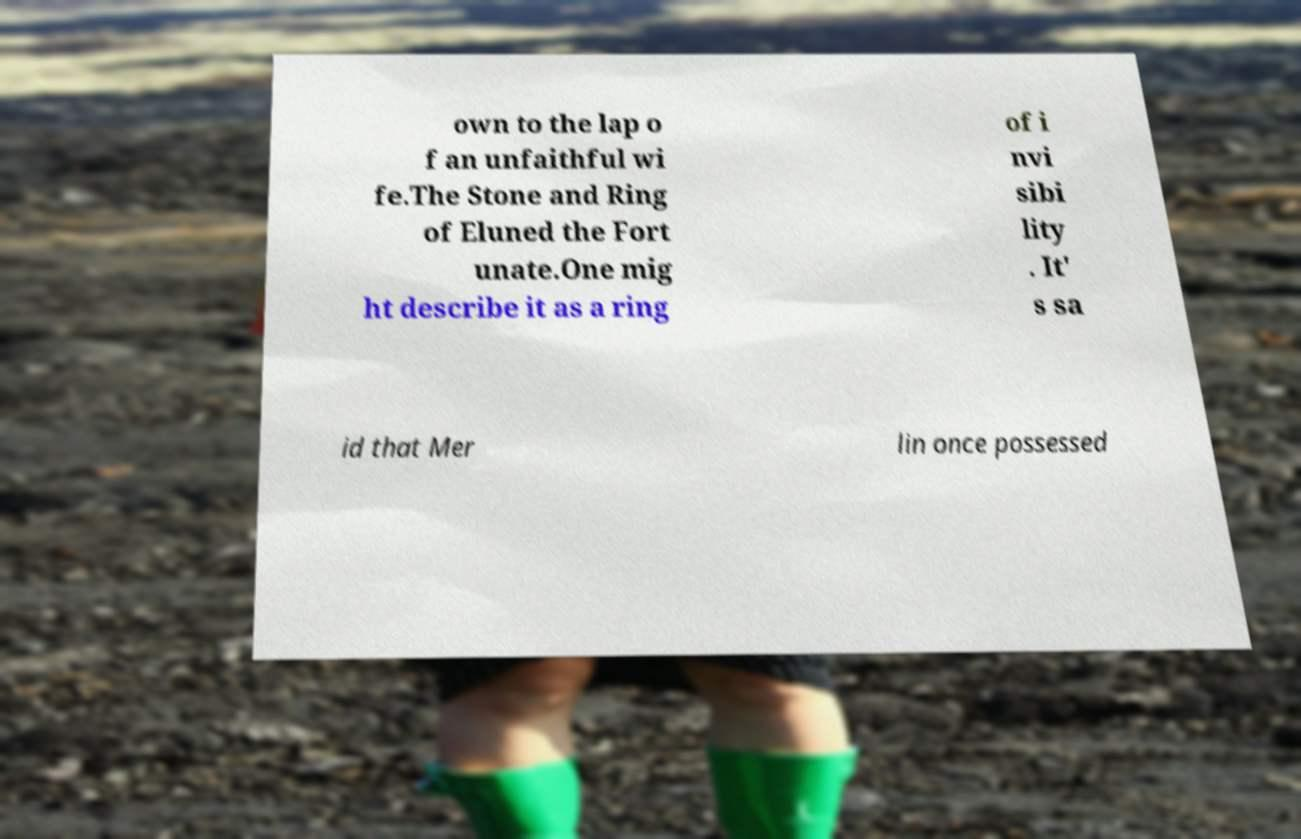For documentation purposes, I need the text within this image transcribed. Could you provide that? own to the lap o f an unfaithful wi fe.The Stone and Ring of Eluned the Fort unate.One mig ht describe it as a ring of i nvi sibi lity . It' s sa id that Mer lin once possessed 